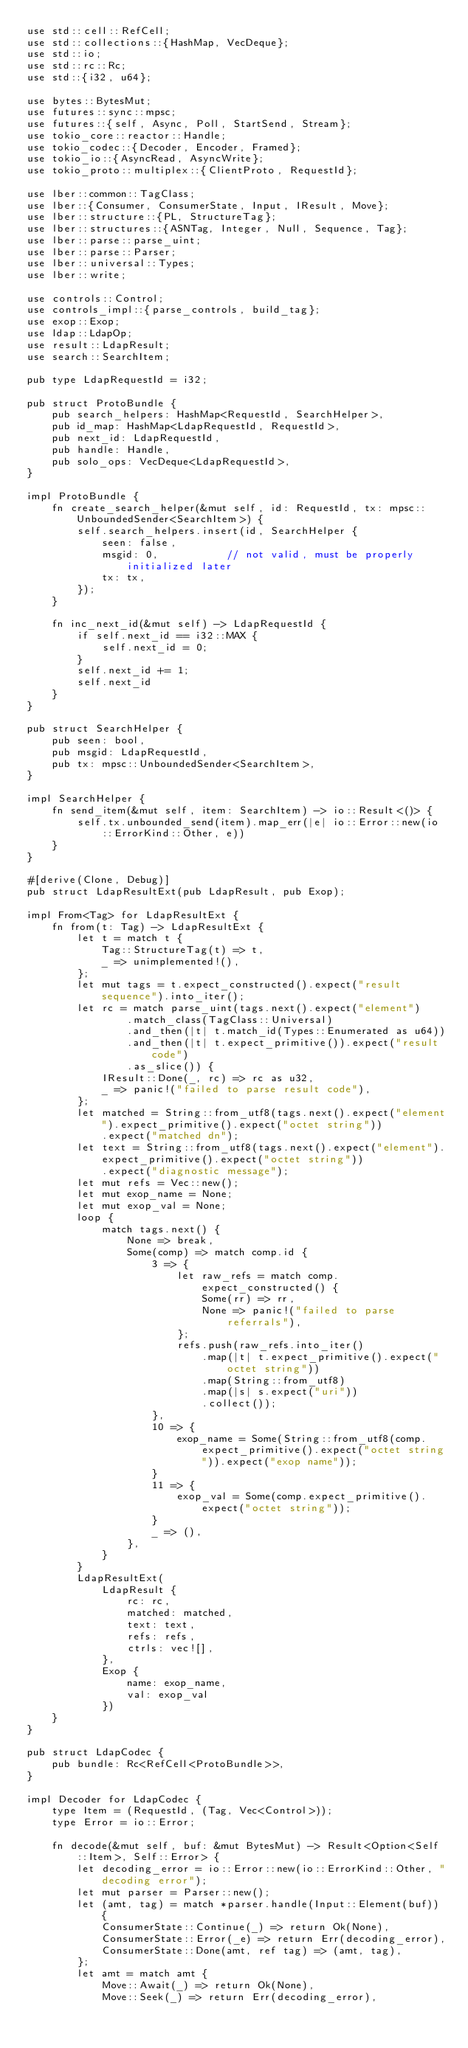<code> <loc_0><loc_0><loc_500><loc_500><_Rust_>use std::cell::RefCell;
use std::collections::{HashMap, VecDeque};
use std::io;
use std::rc::Rc;
use std::{i32, u64};

use bytes::BytesMut;
use futures::sync::mpsc;
use futures::{self, Async, Poll, StartSend, Stream};
use tokio_core::reactor::Handle;
use tokio_codec::{Decoder, Encoder, Framed};
use tokio_io::{AsyncRead, AsyncWrite};
use tokio_proto::multiplex::{ClientProto, RequestId};

use lber::common::TagClass;
use lber::{Consumer, ConsumerState, Input, IResult, Move};
use lber::structure::{PL, StructureTag};
use lber::structures::{ASNTag, Integer, Null, Sequence, Tag};
use lber::parse::parse_uint;
use lber::parse::Parser;
use lber::universal::Types;
use lber::write;

use controls::Control;
use controls_impl::{parse_controls, build_tag};
use exop::Exop;
use ldap::LdapOp;
use result::LdapResult;
use search::SearchItem;

pub type LdapRequestId = i32;

pub struct ProtoBundle {
    pub search_helpers: HashMap<RequestId, SearchHelper>,
    pub id_map: HashMap<LdapRequestId, RequestId>,
    pub next_id: LdapRequestId,
    pub handle: Handle,
    pub solo_ops: VecDeque<LdapRequestId>,
}

impl ProtoBundle {
    fn create_search_helper(&mut self, id: RequestId, tx: mpsc::UnboundedSender<SearchItem>) {
        self.search_helpers.insert(id, SearchHelper {
            seen: false,
            msgid: 0,           // not valid, must be properly initialized later
            tx: tx,
        });
    }

    fn inc_next_id(&mut self) -> LdapRequestId {
        if self.next_id == i32::MAX {
            self.next_id = 0;
        }
        self.next_id += 1;
        self.next_id
    }
}

pub struct SearchHelper {
    pub seen: bool,
    pub msgid: LdapRequestId,
    pub tx: mpsc::UnboundedSender<SearchItem>,
}

impl SearchHelper {
    fn send_item(&mut self, item: SearchItem) -> io::Result<()> {
        self.tx.unbounded_send(item).map_err(|e| io::Error::new(io::ErrorKind::Other, e))
    }
}

#[derive(Clone, Debug)]
pub struct LdapResultExt(pub LdapResult, pub Exop);

impl From<Tag> for LdapResultExt {
    fn from(t: Tag) -> LdapResultExt {
        let t = match t {
            Tag::StructureTag(t) => t,
            _ => unimplemented!(),
        };
        let mut tags = t.expect_constructed().expect("result sequence").into_iter();
        let rc = match parse_uint(tags.next().expect("element")
                .match_class(TagClass::Universal)
                .and_then(|t| t.match_id(Types::Enumerated as u64))
                .and_then(|t| t.expect_primitive()).expect("result code")
                .as_slice()) {
            IResult::Done(_, rc) => rc as u32,
            _ => panic!("failed to parse result code"),
        };
        let matched = String::from_utf8(tags.next().expect("element").expect_primitive().expect("octet string"))
            .expect("matched dn");
        let text = String::from_utf8(tags.next().expect("element").expect_primitive().expect("octet string"))
            .expect("diagnostic message");
        let mut refs = Vec::new();
        let mut exop_name = None;
        let mut exop_val = None;
        loop {
            match tags.next() {
                None => break,
                Some(comp) => match comp.id {
                    3 => {
                        let raw_refs = match comp.expect_constructed() {
                            Some(rr) => rr,
                            None => panic!("failed to parse referrals"),
                        };
                        refs.push(raw_refs.into_iter()
                            .map(|t| t.expect_primitive().expect("octet string"))
                            .map(String::from_utf8)
                            .map(|s| s.expect("uri"))
                            .collect());
                    },
                    10 => {
                        exop_name = Some(String::from_utf8(comp.expect_primitive().expect("octet string")).expect("exop name"));
                    }
                    11 => {
                        exop_val = Some(comp.expect_primitive().expect("octet string"));
                    }
                    _ => (),
                },
            }
        }
        LdapResultExt(
            LdapResult {
                rc: rc,
                matched: matched,
                text: text,
                refs: refs,
                ctrls: vec![],
            },
            Exop {
                name: exop_name,
                val: exop_val
            })
    }
}

pub struct LdapCodec {
    pub bundle: Rc<RefCell<ProtoBundle>>,
}

impl Decoder for LdapCodec {
    type Item = (RequestId, (Tag, Vec<Control>));
    type Error = io::Error;

    fn decode(&mut self, buf: &mut BytesMut) -> Result<Option<Self::Item>, Self::Error> {
        let decoding_error = io::Error::new(io::ErrorKind::Other, "decoding error");
        let mut parser = Parser::new();
        let (amt, tag) = match *parser.handle(Input::Element(buf)) {
            ConsumerState::Continue(_) => return Ok(None),
            ConsumerState::Error(_e) => return Err(decoding_error),
            ConsumerState::Done(amt, ref tag) => (amt, tag),
        };
        let amt = match amt {
            Move::Await(_) => return Ok(None),
            Move::Seek(_) => return Err(decoding_error),</code> 